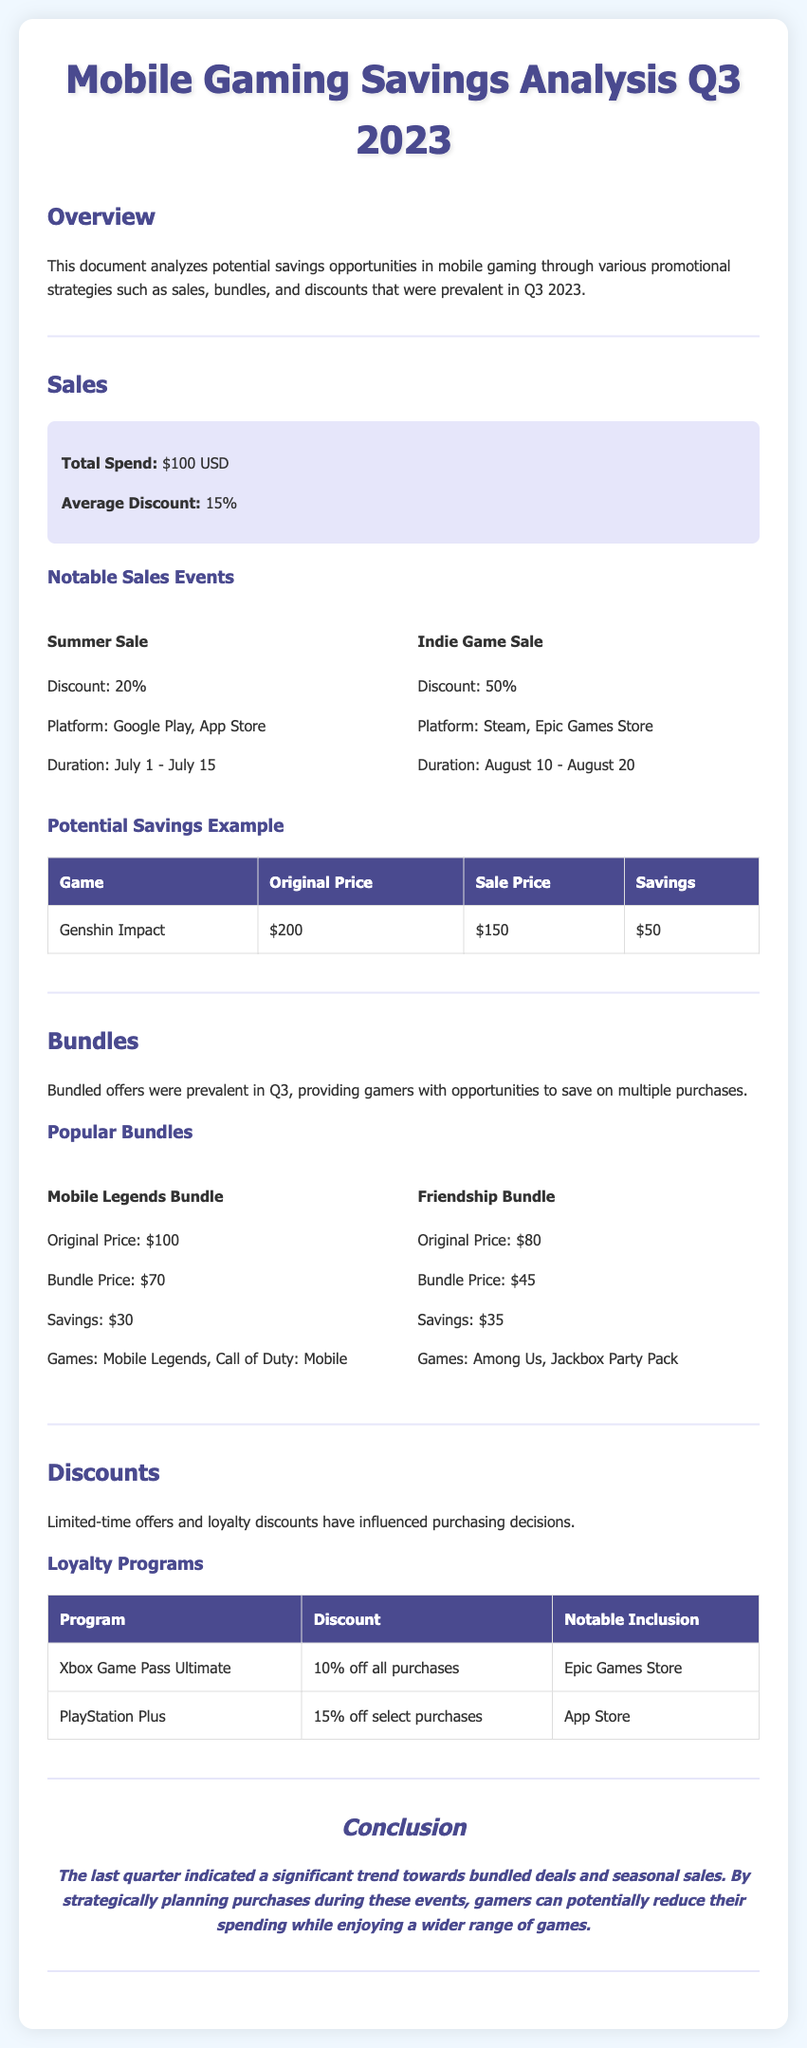What was the total spend on mobile gaming in Q3 2023? The total spend is specified in the document as $100 USD.
Answer: $100 USD What was the average discount offered during Q3 2023? The document states that the average discount was 15%.
Answer: 15% What was the discount percentage for the Summer Sale? The Summer Sale discount is mentioned as 20%.
Answer: 20% What was the savings amount for the Mobile Legends Bundle? The document states that the savings for the Mobile Legends Bundle was $30.
Answer: $30 Which loyalty program offered a 15% discount? The document lists the PlayStation Plus as the program offering a 15% discount.
Answer: PlayStation Plus How much was the savings for Genshin Impact during the notable sales? The savings for Genshin Impact is stated as $50.
Answer: $50 Which two platforms were noted for the Summer Sale? The document specifies that the platforms for the Summer Sale were Google Play and App Store.
Answer: Google Play, App Store What was the bundle price for the Friendship Bundle? The document notes the bundle price for the Friendship Bundle as $45.
Answer: $45 What is the conclusion about spending trends in Q3 2023? The conclusion states that there was a significant trend towards bundled deals and seasonal sales.
Answer: Bundled deals and seasonal sales 